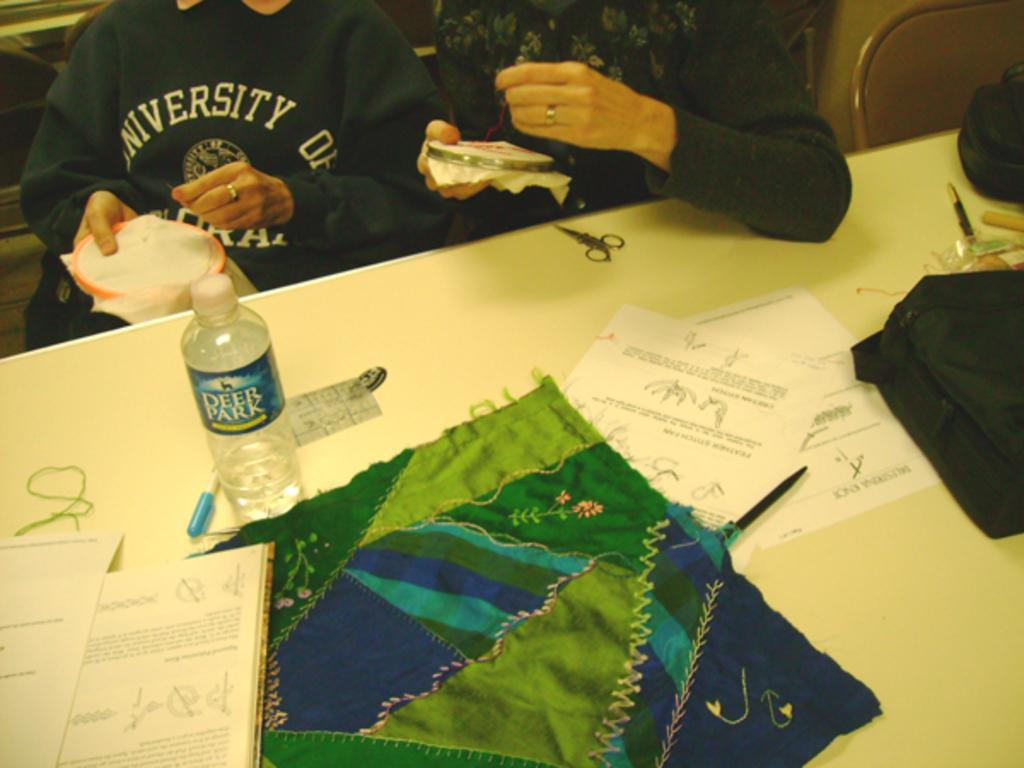Describe this image in one or two sentences. This image consists of two persons wearing black dresses. In the front, there is a table on which there are papers, pens, scissors, and a bottle along with a cloth. It looks it is clicked in a room. On the right, there is a chair. 